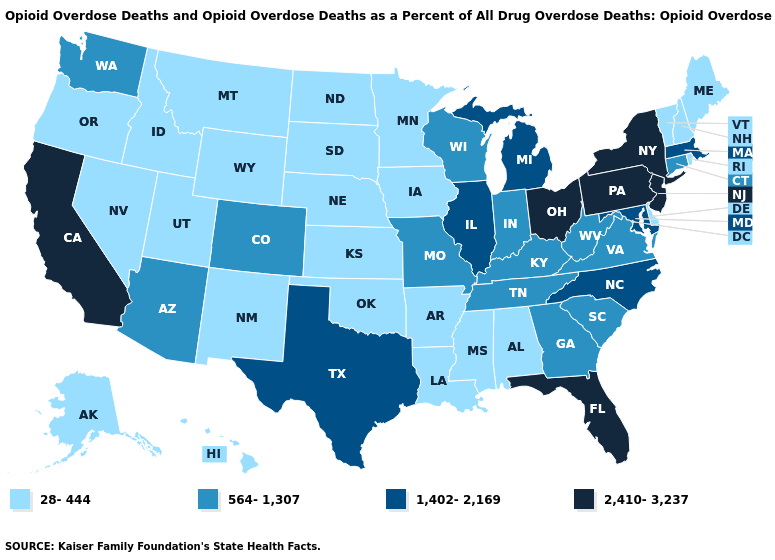Which states hav the highest value in the MidWest?
Keep it brief. Ohio. What is the value of Indiana?
Short answer required. 564-1,307. Name the states that have a value in the range 2,410-3,237?
Keep it brief. California, Florida, New Jersey, New York, Ohio, Pennsylvania. Does Wyoming have a lower value than New York?
Quick response, please. Yes. How many symbols are there in the legend?
Be succinct. 4. Name the states that have a value in the range 2,410-3,237?
Concise answer only. California, Florida, New Jersey, New York, Ohio, Pennsylvania. What is the value of Vermont?
Be succinct. 28-444. How many symbols are there in the legend?
Keep it brief. 4. Does Texas have the lowest value in the USA?
Be succinct. No. Name the states that have a value in the range 564-1,307?
Be succinct. Arizona, Colorado, Connecticut, Georgia, Indiana, Kentucky, Missouri, South Carolina, Tennessee, Virginia, Washington, West Virginia, Wisconsin. What is the value of North Dakota?
Answer briefly. 28-444. What is the value of North Carolina?
Quick response, please. 1,402-2,169. What is the highest value in states that border Nevada?
Give a very brief answer. 2,410-3,237. Does the first symbol in the legend represent the smallest category?
Quick response, please. Yes. Does Michigan have a lower value than Kansas?
Write a very short answer. No. 